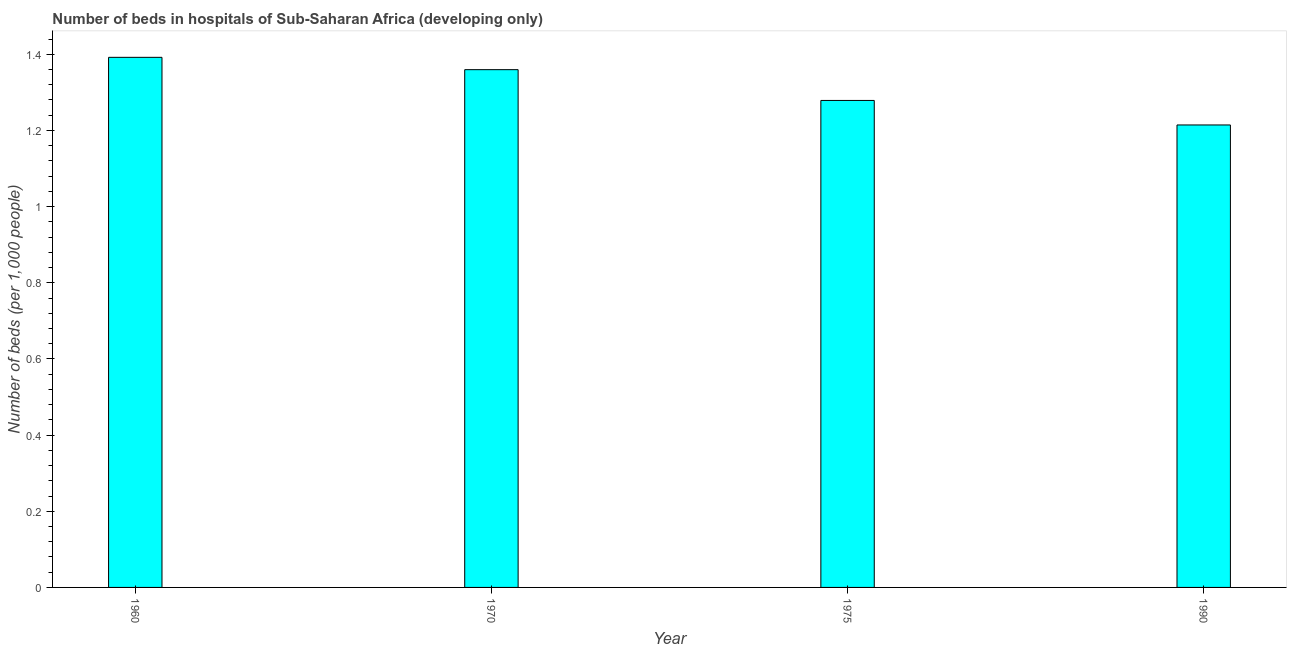Does the graph contain any zero values?
Provide a short and direct response. No. Does the graph contain grids?
Provide a short and direct response. No. What is the title of the graph?
Ensure brevity in your answer.  Number of beds in hospitals of Sub-Saharan Africa (developing only). What is the label or title of the X-axis?
Offer a very short reply. Year. What is the label or title of the Y-axis?
Offer a terse response. Number of beds (per 1,0 people). What is the number of hospital beds in 1975?
Provide a succinct answer. 1.28. Across all years, what is the maximum number of hospital beds?
Ensure brevity in your answer.  1.39. Across all years, what is the minimum number of hospital beds?
Offer a terse response. 1.21. In which year was the number of hospital beds maximum?
Provide a succinct answer. 1960. In which year was the number of hospital beds minimum?
Your response must be concise. 1990. What is the sum of the number of hospital beds?
Offer a very short reply. 5.24. What is the difference between the number of hospital beds in 1960 and 1970?
Your response must be concise. 0.03. What is the average number of hospital beds per year?
Provide a succinct answer. 1.31. What is the median number of hospital beds?
Ensure brevity in your answer.  1.32. In how many years, is the number of hospital beds greater than 1.12 %?
Offer a terse response. 4. Do a majority of the years between 1990 and 1970 (inclusive) have number of hospital beds greater than 1 %?
Your answer should be very brief. Yes. What is the ratio of the number of hospital beds in 1960 to that in 1975?
Your response must be concise. 1.09. Is the difference between the number of hospital beds in 1960 and 1970 greater than the difference between any two years?
Give a very brief answer. No. What is the difference between the highest and the second highest number of hospital beds?
Keep it short and to the point. 0.03. What is the difference between the highest and the lowest number of hospital beds?
Your answer should be compact. 0.18. In how many years, is the number of hospital beds greater than the average number of hospital beds taken over all years?
Your answer should be compact. 2. How many years are there in the graph?
Offer a terse response. 4. What is the Number of beds (per 1,000 people) of 1960?
Your answer should be compact. 1.39. What is the Number of beds (per 1,000 people) in 1970?
Your answer should be very brief. 1.36. What is the Number of beds (per 1,000 people) of 1975?
Keep it short and to the point. 1.28. What is the Number of beds (per 1,000 people) of 1990?
Your response must be concise. 1.21. What is the difference between the Number of beds (per 1,000 people) in 1960 and 1970?
Make the answer very short. 0.03. What is the difference between the Number of beds (per 1,000 people) in 1960 and 1975?
Offer a terse response. 0.11. What is the difference between the Number of beds (per 1,000 people) in 1960 and 1990?
Provide a succinct answer. 0.18. What is the difference between the Number of beds (per 1,000 people) in 1970 and 1975?
Your response must be concise. 0.08. What is the difference between the Number of beds (per 1,000 people) in 1970 and 1990?
Make the answer very short. 0.15. What is the difference between the Number of beds (per 1,000 people) in 1975 and 1990?
Keep it short and to the point. 0.06. What is the ratio of the Number of beds (per 1,000 people) in 1960 to that in 1975?
Your answer should be compact. 1.09. What is the ratio of the Number of beds (per 1,000 people) in 1960 to that in 1990?
Offer a terse response. 1.15. What is the ratio of the Number of beds (per 1,000 people) in 1970 to that in 1975?
Keep it short and to the point. 1.06. What is the ratio of the Number of beds (per 1,000 people) in 1970 to that in 1990?
Give a very brief answer. 1.12. What is the ratio of the Number of beds (per 1,000 people) in 1975 to that in 1990?
Keep it short and to the point. 1.05. 